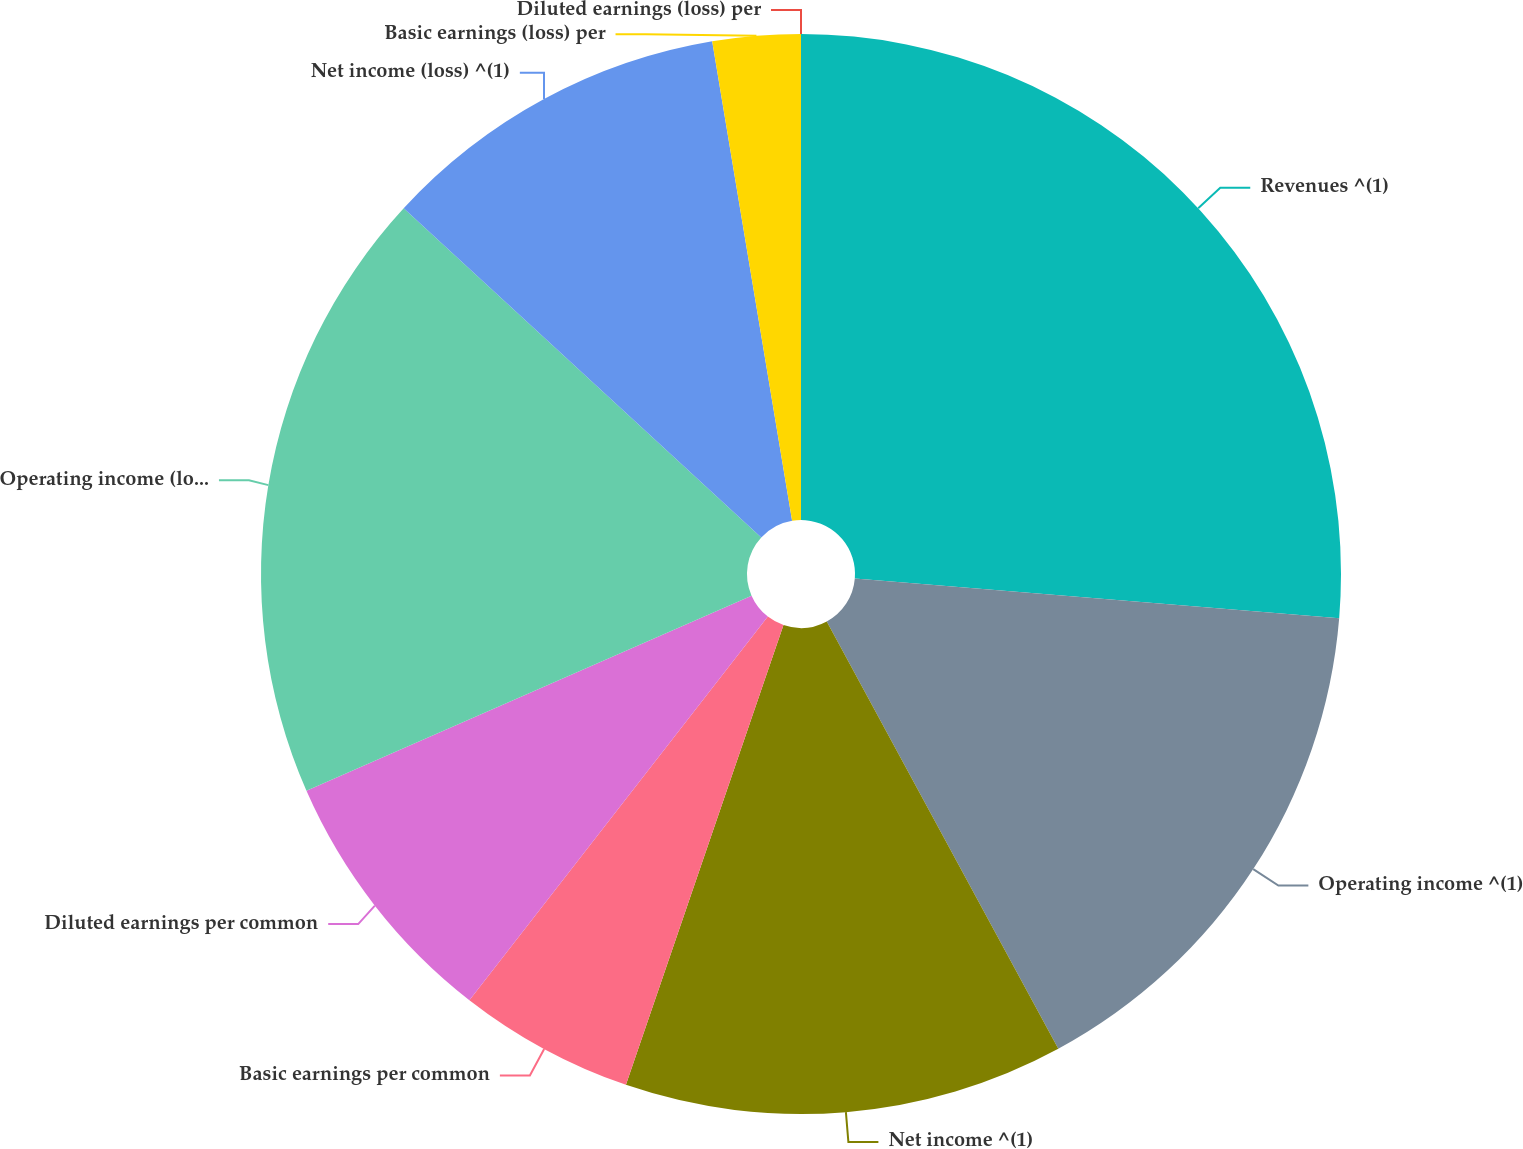Convert chart to OTSL. <chart><loc_0><loc_0><loc_500><loc_500><pie_chart><fcel>Revenues ^(1)<fcel>Operating income ^(1)<fcel>Net income ^(1)<fcel>Basic earnings per common<fcel>Diluted earnings per common<fcel>Operating income (loss) ^(1)<fcel>Net income (loss) ^(1)<fcel>Basic earnings (loss) per<fcel>Diluted earnings (loss) per<nl><fcel>26.31%<fcel>15.79%<fcel>13.16%<fcel>5.27%<fcel>7.9%<fcel>18.42%<fcel>10.53%<fcel>2.63%<fcel>0.0%<nl></chart> 